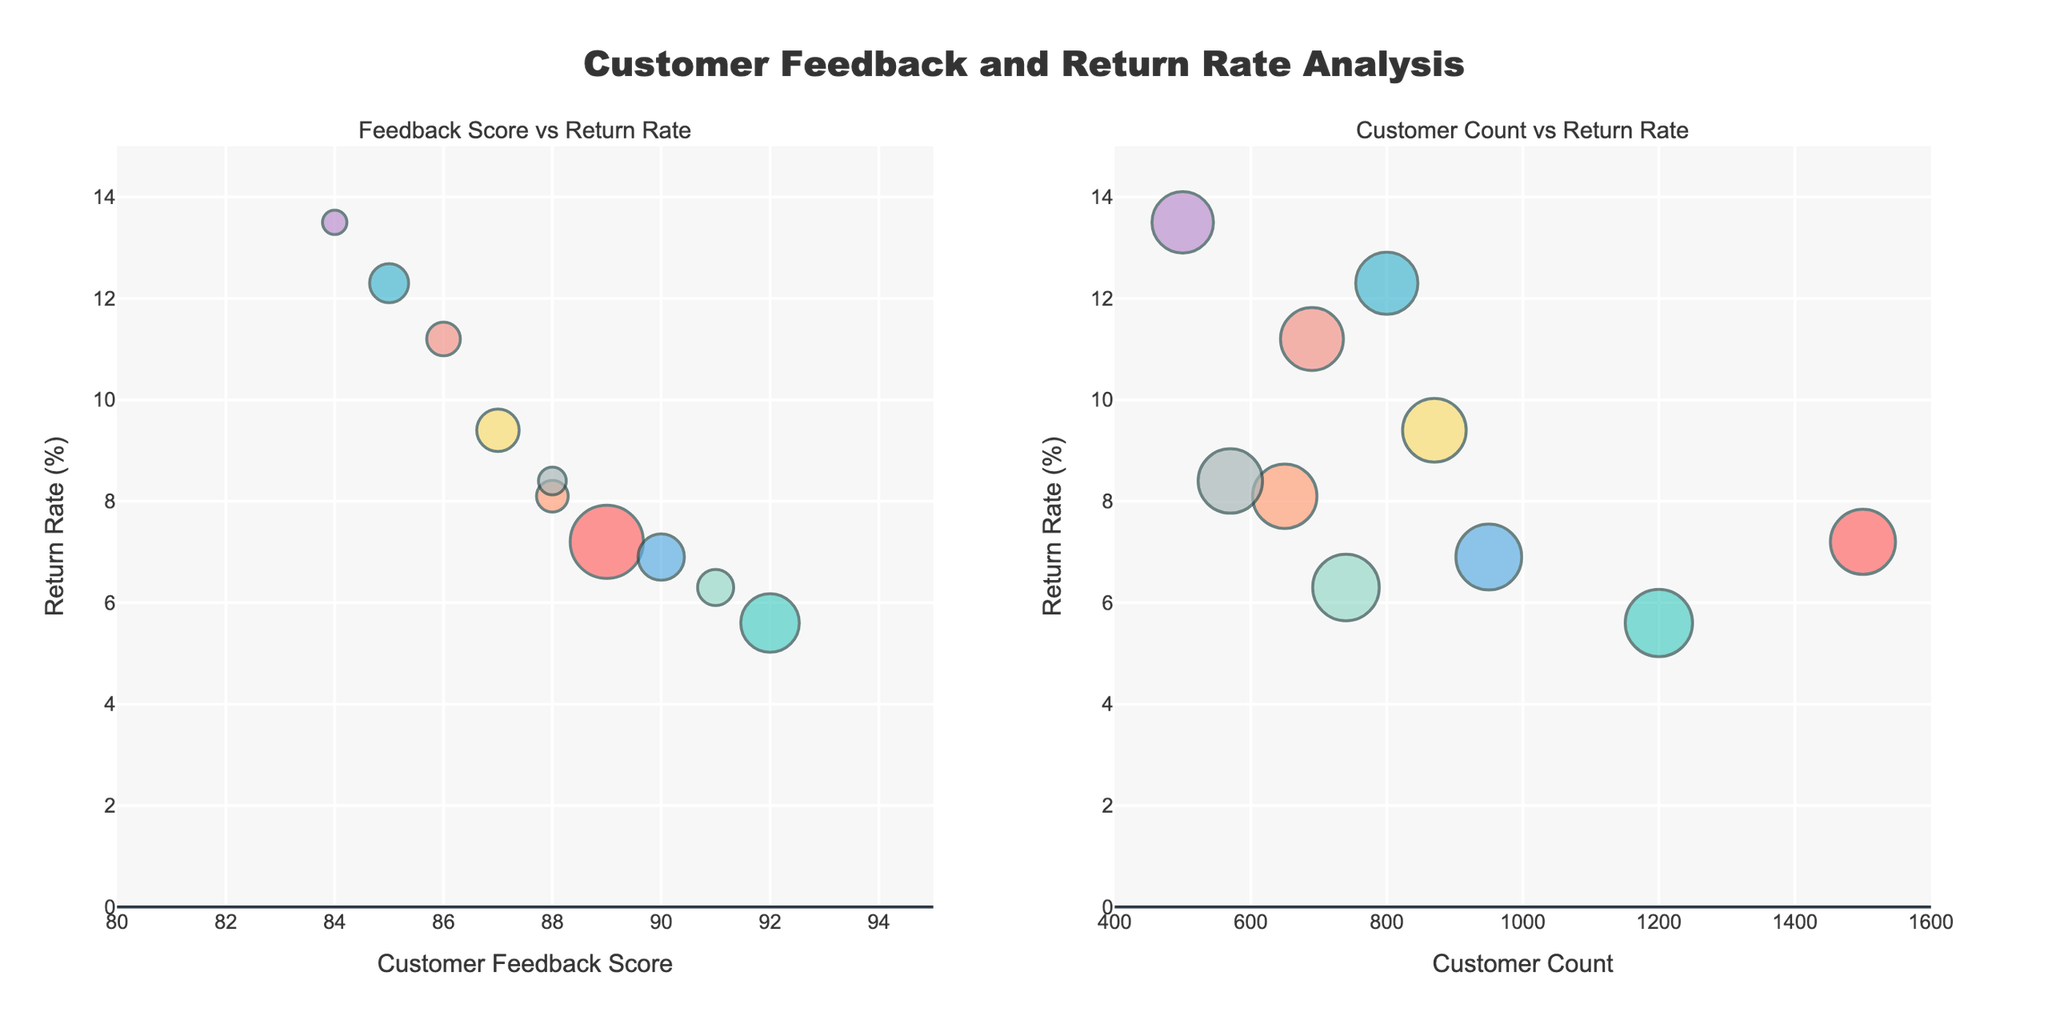What's the title of the figure? The title is displayed at the top center of the figure and is "Customer Feedback and Return Rate Analysis".
Answer: Customer Feedback and Return Rate Analysis What's the feedback score range shown on the x-axis of the first subplot? By examining the x-axis of the first subplot, the range for the Customer Feedback Score is from 80 to 95.
Answer: 80 to 95 How many customer counts are shown on the x-axis of the second subplot? By looking at the ticks on the x-axis of the second subplot, the customer counts range from 400 to 1600.
Answer: 400 to 1600 Which product has the highest return rate, and what is that rate? The bubble representing the Electric Scooter is located at the highest y-axis value among the points, indicating the highest return rate. Its return rate is 13.5%.
Answer: Electric Scooter, 13.5% Which product has the lowest return rate, and what is that rate? The bubble for Laptop_Pro is at the lowest position on the y-axis, indicating the lowest return rate of 5.6%.
Answer: Laptop_Pro, 5.6% Between Smartphone_X and Gaming_Console, which has a higher feedback score, and by how much? By comparing the x-axis positions of Smartphone_X and Gaming_Console in the first subplot, Smartphone_X has a feedback score of 89, and Gaming_Console has a score of 91. The difference is 91 - 89 = 2.
Answer: Gaming_Console, 2 What is the average return rate for products with a feedback score greater than 90? Products with feedback scores greater than 90 are Laptop_Pro, Gaming_Console, and Fitness_Tracker. Their respective return rates are 5.6, 6.3, and 6.9. Calculating the average: (5.6 + 6.3 + 6.9) / 3 = 6.27.
Answer: 6.27 Describe the correlation between Customer Feedback Score and Return Rate. As seen in the first subplot, higher feedback scores tend to correlate with lower return rates. The points generally move from top-left to bottom-right.
Answer: Negative correlation What product has the highest combined customer count and return rate? By inspecting both subplots, the Smartphone_X is prominently represented with a customer count of 1500 and a return rate of 7.2%, indicating the highest combined value when considering count and return percentages visually.
Answer: Smartphone_X 